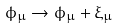<formula> <loc_0><loc_0><loc_500><loc_500>\phi _ { \mu } \to \phi _ { \mu } + \xi _ { \mu }</formula> 